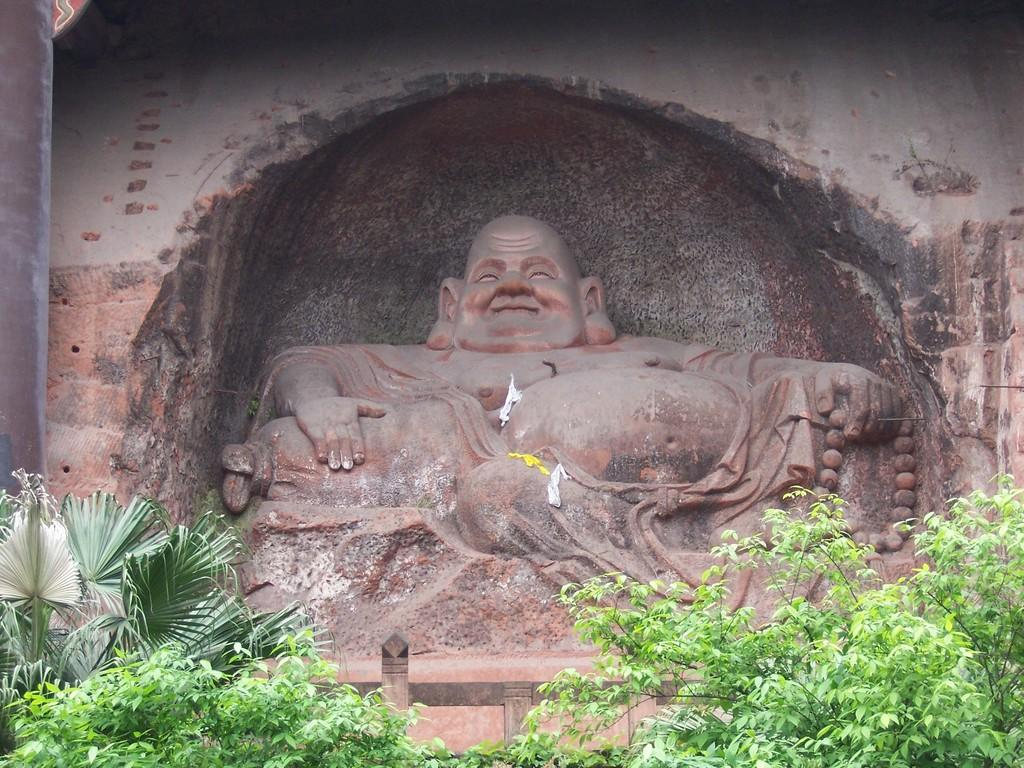What is the main subject of the image? The main subject of the image is a sculpture of laughing Buddha. What can be seen in front of the sculpture? There are many plants in front of the sculpture. What type of fiction is being read by the laughing Buddha in the image? There is no book or any form of fiction present in the image; it features a sculpture of laughing Buddha surrounded by plants. 